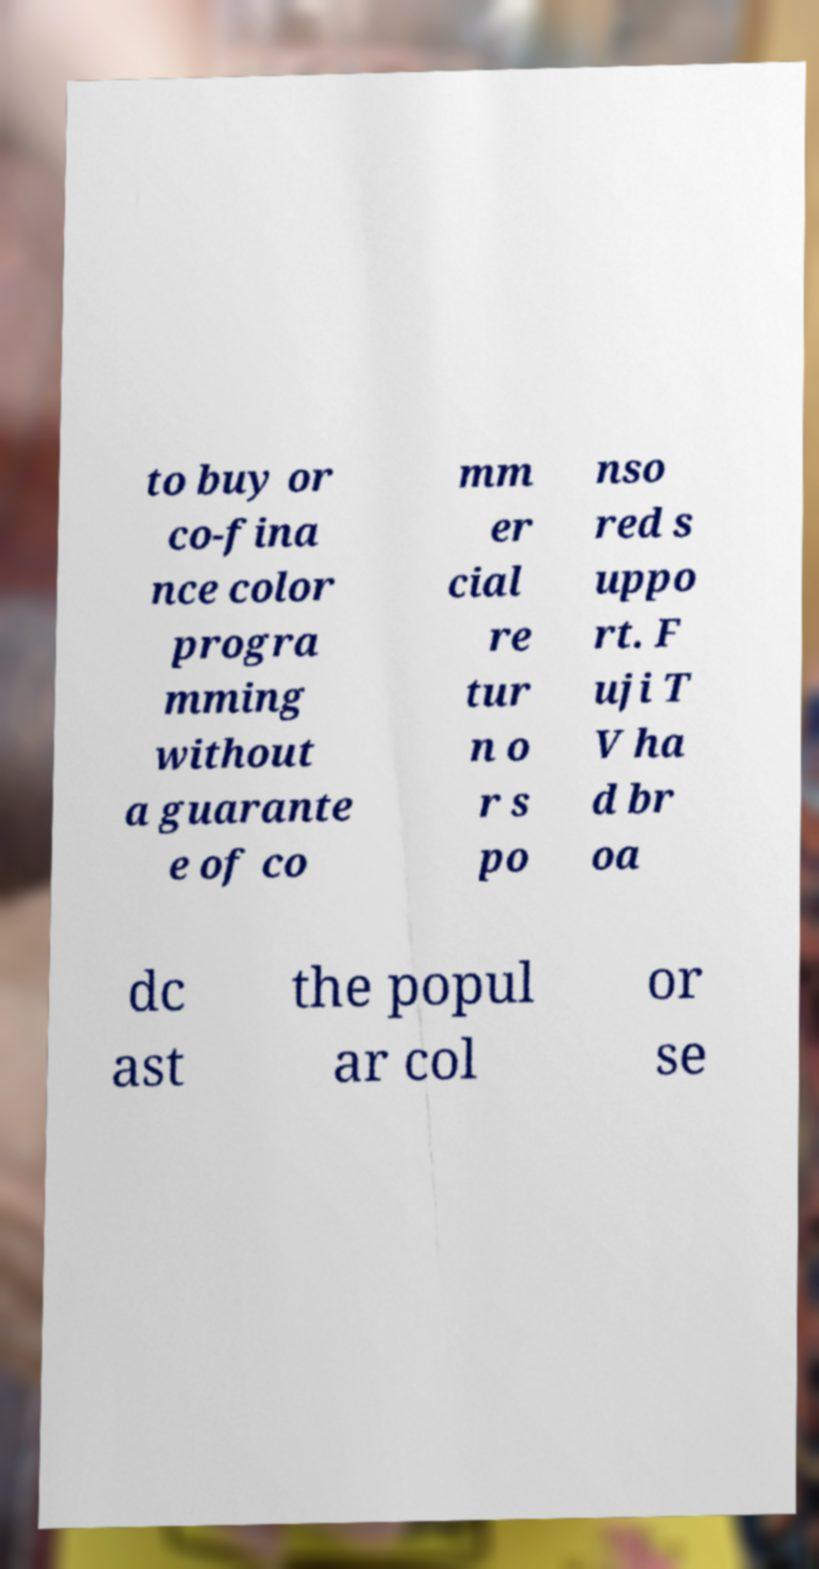Could you extract and type out the text from this image? to buy or co-fina nce color progra mming without a guarante e of co mm er cial re tur n o r s po nso red s uppo rt. F uji T V ha d br oa dc ast the popul ar col or se 